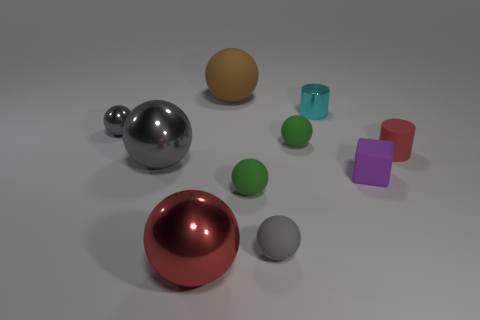What is the size of the ball that is the same color as the rubber cylinder?
Give a very brief answer. Large. There is a large shiny thing that is the same color as the small matte cylinder; what shape is it?
Keep it short and to the point. Sphere. Are there the same number of shiny balls behind the brown rubber object and metal spheres that are right of the purple matte thing?
Your answer should be compact. Yes. There is a large rubber object that is the same shape as the tiny gray rubber thing; what is its color?
Ensure brevity in your answer.  Brown. Are there any other things of the same color as the block?
Keep it short and to the point. No. What number of metallic things are either tiny gray spheres or red things?
Offer a terse response. 2. Does the small matte cylinder have the same color as the tiny metallic sphere?
Your answer should be very brief. No. Are there more large gray shiny things that are behind the small metallic cylinder than blue matte objects?
Ensure brevity in your answer.  No. How many other objects are the same material as the tiny cyan object?
Your answer should be compact. 3. How many small things are either red metallic things or green balls?
Keep it short and to the point. 2. 